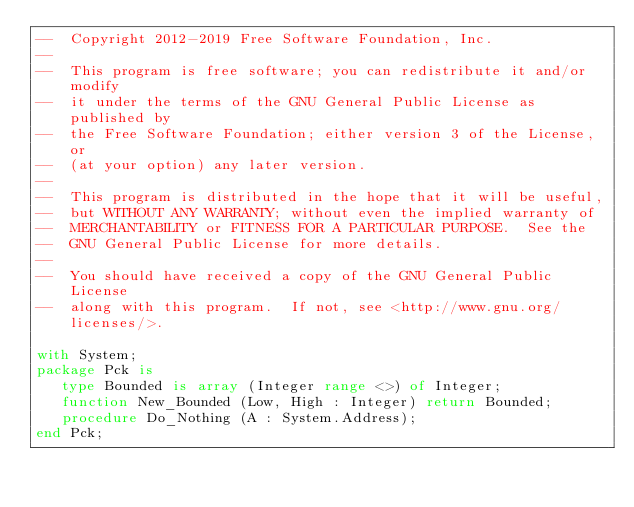Convert code to text. <code><loc_0><loc_0><loc_500><loc_500><_Ada_>--  Copyright 2012-2019 Free Software Foundation, Inc.
--
--  This program is free software; you can redistribute it and/or modify
--  it under the terms of the GNU General Public License as published by
--  the Free Software Foundation; either version 3 of the License, or
--  (at your option) any later version.
--
--  This program is distributed in the hope that it will be useful,
--  but WITHOUT ANY WARRANTY; without even the implied warranty of
--  MERCHANTABILITY or FITNESS FOR A PARTICULAR PURPOSE.  See the
--  GNU General Public License for more details.
--
--  You should have received a copy of the GNU General Public License
--  along with this program.  If not, see <http://www.gnu.org/licenses/>.

with System;
package Pck is
   type Bounded is array (Integer range <>) of Integer;
   function New_Bounded (Low, High : Integer) return Bounded;
   procedure Do_Nothing (A : System.Address);
end Pck;
</code> 